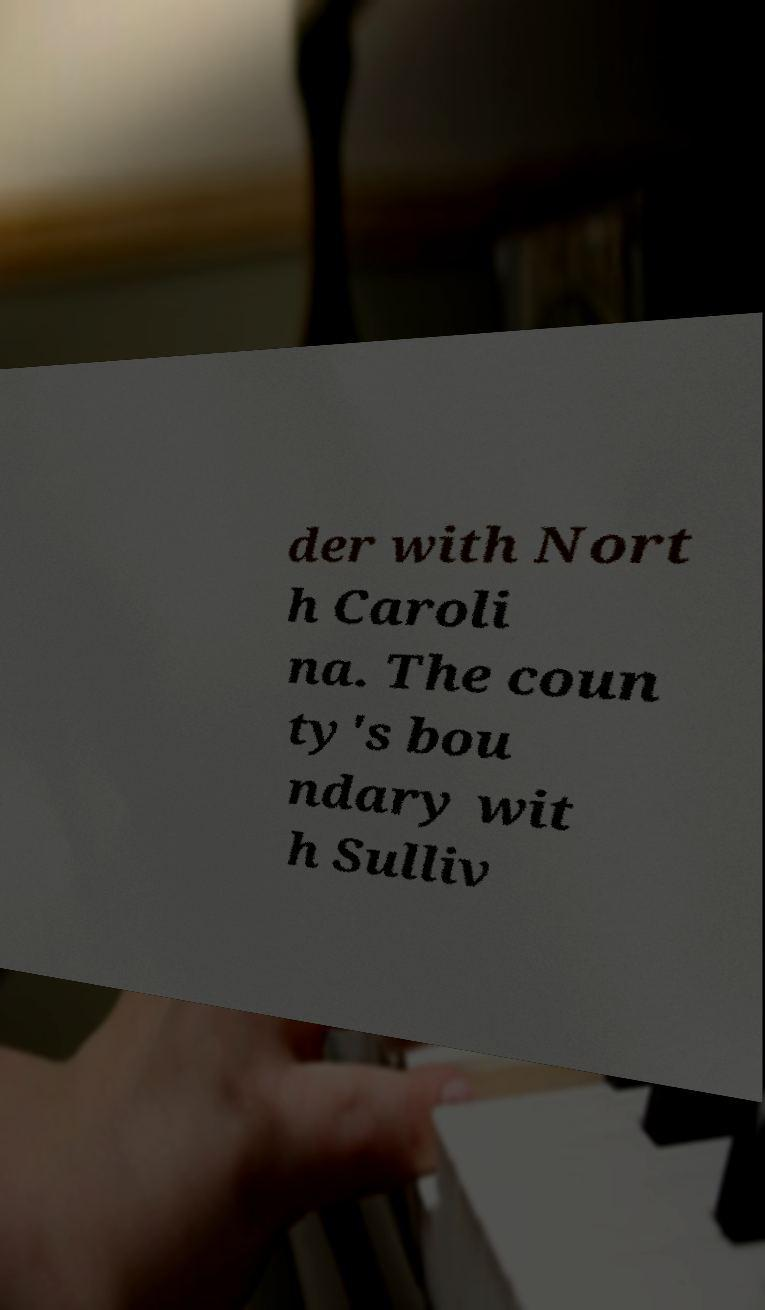There's text embedded in this image that I need extracted. Can you transcribe it verbatim? der with Nort h Caroli na. The coun ty's bou ndary wit h Sulliv 